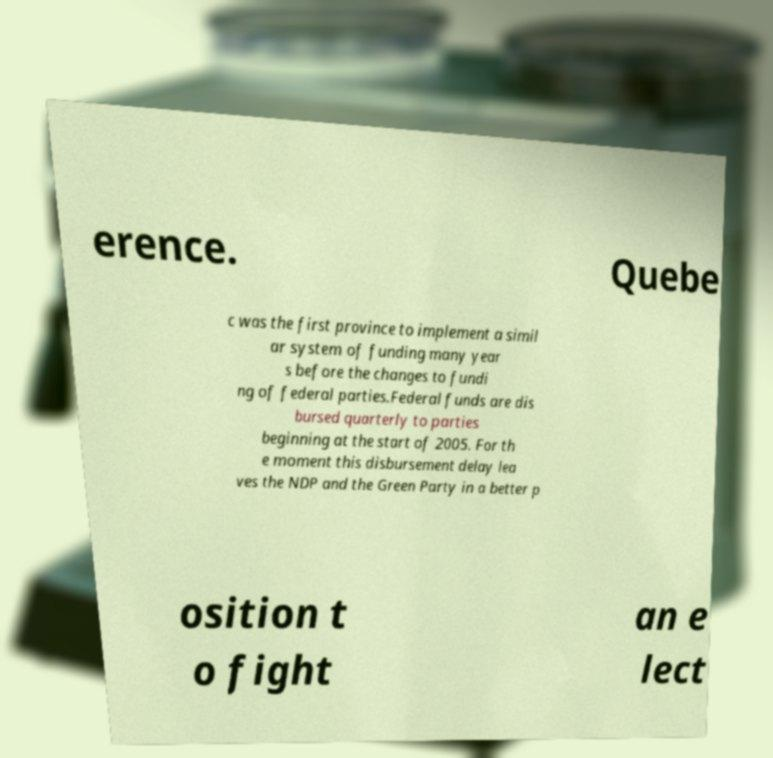What messages or text are displayed in this image? I need them in a readable, typed format. erence. Quebe c was the first province to implement a simil ar system of funding many year s before the changes to fundi ng of federal parties.Federal funds are dis bursed quarterly to parties beginning at the start of 2005. For th e moment this disbursement delay lea ves the NDP and the Green Party in a better p osition t o fight an e lect 